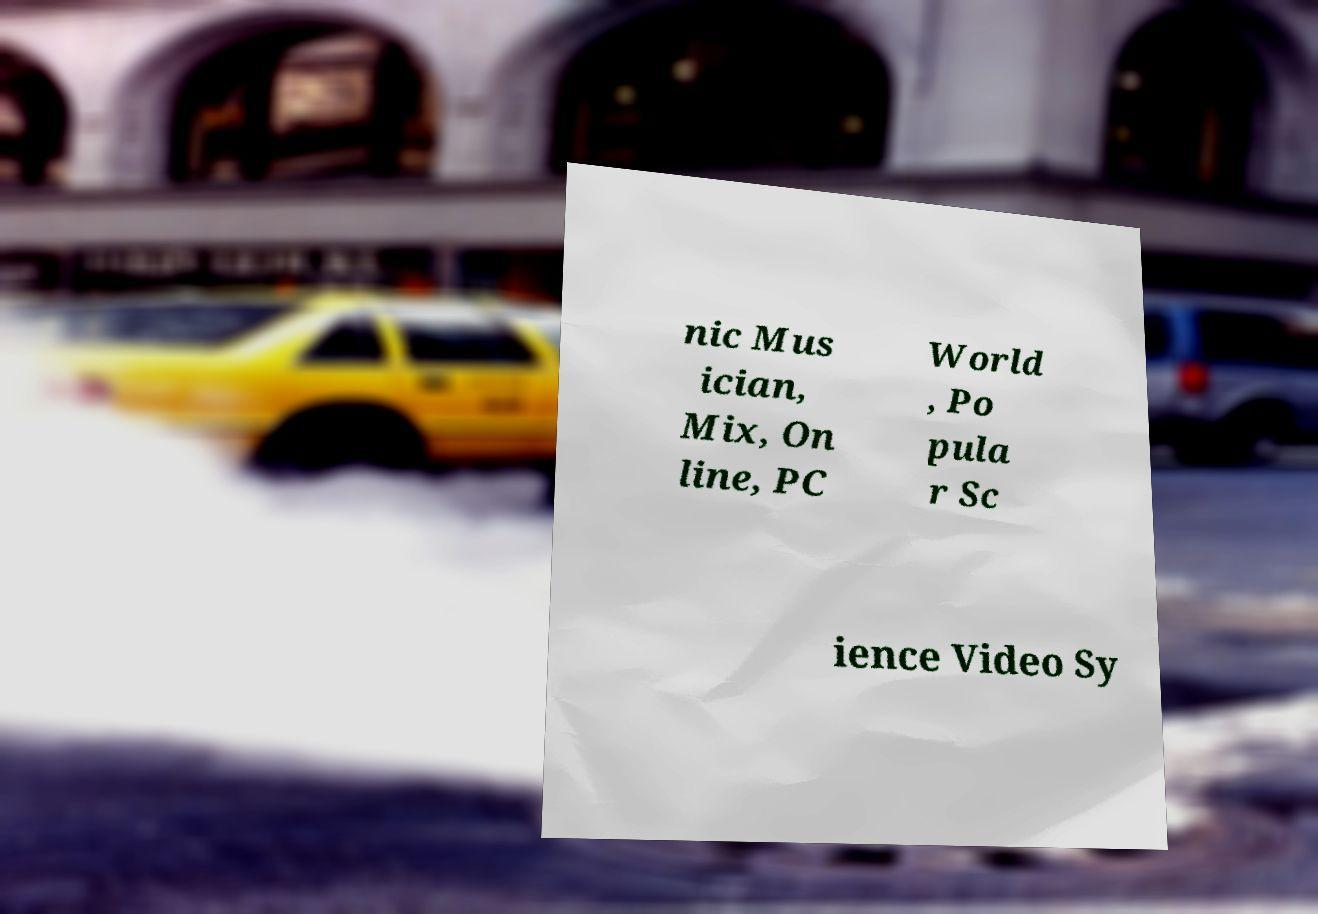What messages or text are displayed in this image? I need them in a readable, typed format. nic Mus ician, Mix, On line, PC World , Po pula r Sc ience Video Sy 